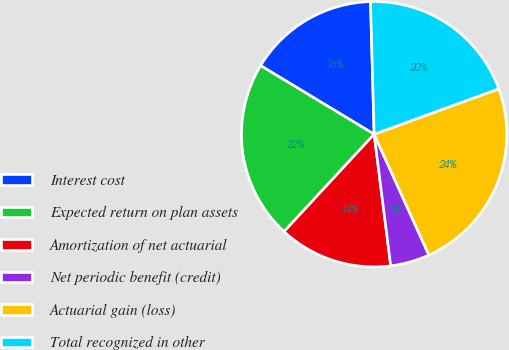Convert chart. <chart><loc_0><loc_0><loc_500><loc_500><pie_chart><fcel>Interest cost<fcel>Expected return on plan assets<fcel>Amortization of net actuarial<fcel>Net periodic benefit (credit)<fcel>Actuarial gain (loss)<fcel>Total recognized in other<nl><fcel>15.92%<fcel>21.77%<fcel>13.88%<fcel>4.78%<fcel>23.79%<fcel>19.87%<nl></chart> 